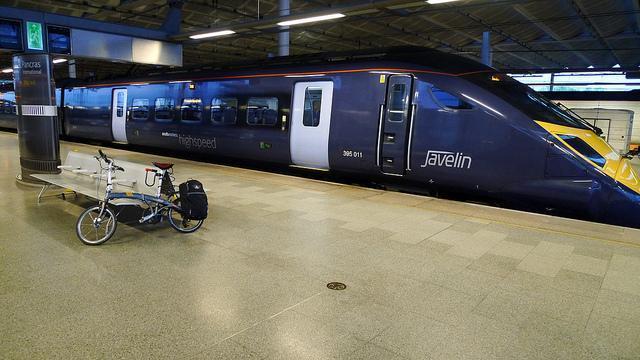How can one tell where the doors are on the train?
Choose the right answer and clarify with the format: 'Answer: answer
Rationale: rationale.'
Options: Door porter, people boarding, big sign, white color. Answer: white color.
Rationale: The body of the train is dark. the doors have been painted differently in order to increase their visibility. 